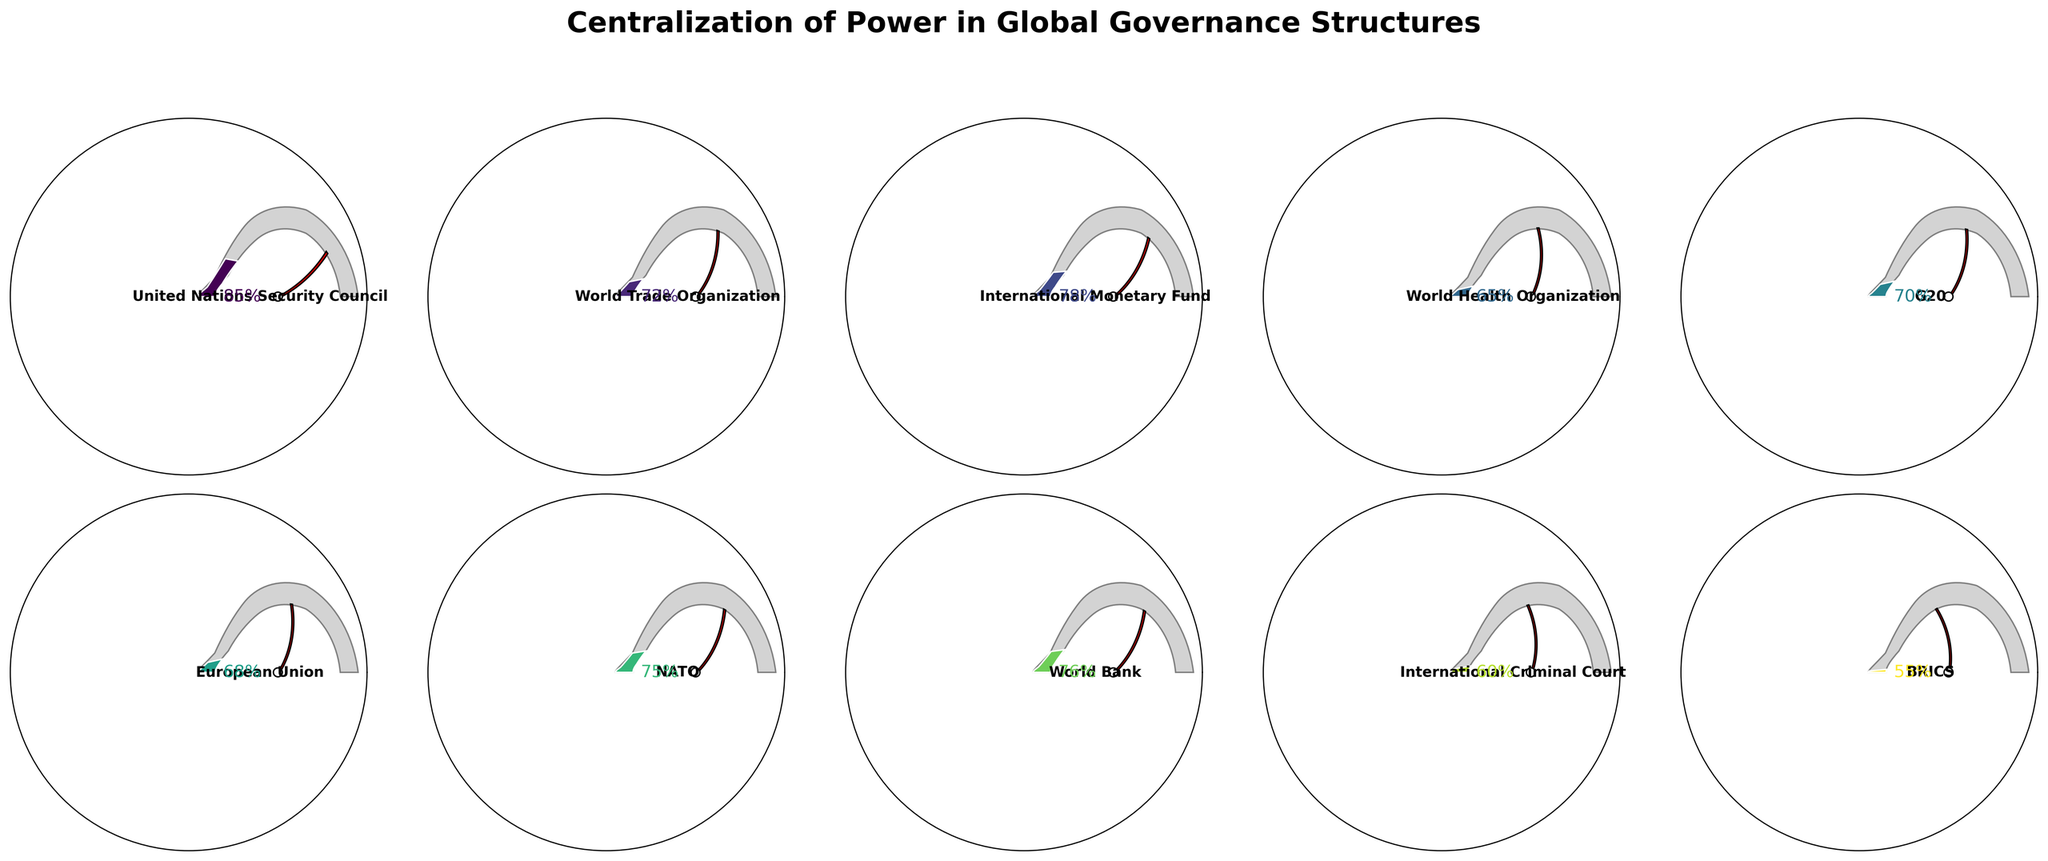What is the centralization percentage of the United Nations Security Council? The centralization percentage for the United Nations Security Council is mentioned next to its name on the gauge chart, which shows 85%.
Answer: 85% Which global governance structure has the lowest centralization percentage? To determine the entity with the lowest centralization, look at each gauge chart and compare the centralization percentages. BRICS has the lowest percentage at 55%.
Answer: BRICS What is the average centralization percentage across all entities? Sum all centralization percentages: (85 + 72 + 78 + 65 + 70 + 68 + 75 + 76 + 60 + 55) = 704. Then divide by the number of entities, which is 10. 704 / 10 = 70.4
Answer: 70.4 Which entities have a centralization percentage greater than 70%? Compare each centralization percentage to 70%. The entities exceeding 70% are:
- United Nations Security Council: 85%
- World Trade Organization: 72%
- International Monetary Fund: 78%
- NATO: 75%
- World Bank: 76%
Answer: United Nations Security Council, World Trade Organization, International Monetary Fund, NATO, World Bank How many entities have a centralization percentage between 60% and 75%? Count the entities with percentages falling within the 60% to 75% range:
- World Health Organization: 65%
- G20: 70%
- European Union: 68%
- NATO: 75%
- World Bank: 76% (excluded)
- International Criminal Court: 60%
Entities within this range: 5
Answer: 5 What is the difference between the highest and lowest centralization percentages? The highest centralization percentage is 85% (United Nations Security Council) and the lowest is 55% (BRICS). The difference is 85 - 55 = 30
Answer: 30 What is the centralization percentage of the European Union? The centralization percentage next to European Union on the gauge chart is 68%.
Answer: 68% Among the entities listed, how many have a centralization percentage below the average percentage calculated? The average percentage is 70.4. Entities below 70.4%:
- World Health Organization: 65%
- European Union: 68%
- International Criminal Court: 60%
- BRICS: 55%
Count: 4
Answer: 4 